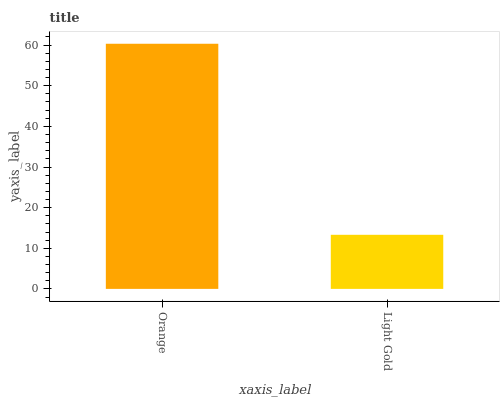Is Light Gold the minimum?
Answer yes or no. Yes. Is Orange the maximum?
Answer yes or no. Yes. Is Light Gold the maximum?
Answer yes or no. No. Is Orange greater than Light Gold?
Answer yes or no. Yes. Is Light Gold less than Orange?
Answer yes or no. Yes. Is Light Gold greater than Orange?
Answer yes or no. No. Is Orange less than Light Gold?
Answer yes or no. No. Is Orange the high median?
Answer yes or no. Yes. Is Light Gold the low median?
Answer yes or no. Yes. Is Light Gold the high median?
Answer yes or no. No. Is Orange the low median?
Answer yes or no. No. 